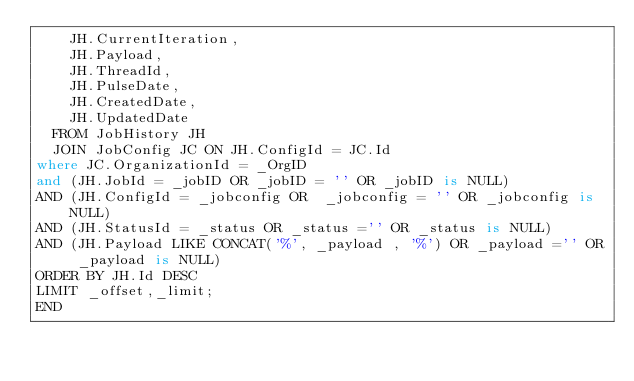<code> <loc_0><loc_0><loc_500><loc_500><_SQL_>    JH.CurrentIteration,
    JH.Payload,
    JH.ThreadId,
    JH.PulseDate,
    JH.CreatedDate,
    JH.UpdatedDate
  FROM JobHistory JH
  JOIN JobConfig JC ON JH.ConfigId = JC.Id
where JC.OrganizationId = _OrgID
and (JH.JobId = _jobID OR _jobID = '' OR _jobID is NULL)
AND (JH.ConfigId = _jobconfig OR  _jobconfig = '' OR _jobconfig is NULL)
AND (JH.StatusId = _status OR _status ='' OR _status is NULL)
AND (JH.Payload LIKE CONCAT('%', _payload , '%') OR _payload ='' OR _payload is NULL)
ORDER BY JH.Id DESC
LIMIT _offset,_limit;
END</code> 